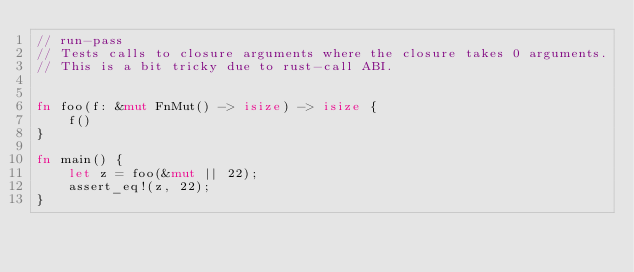<code> <loc_0><loc_0><loc_500><loc_500><_Rust_>// run-pass
// Tests calls to closure arguments where the closure takes 0 arguments.
// This is a bit tricky due to rust-call ABI.


fn foo(f: &mut FnMut() -> isize) -> isize {
    f()
}

fn main() {
    let z = foo(&mut || 22);
    assert_eq!(z, 22);
}
</code> 